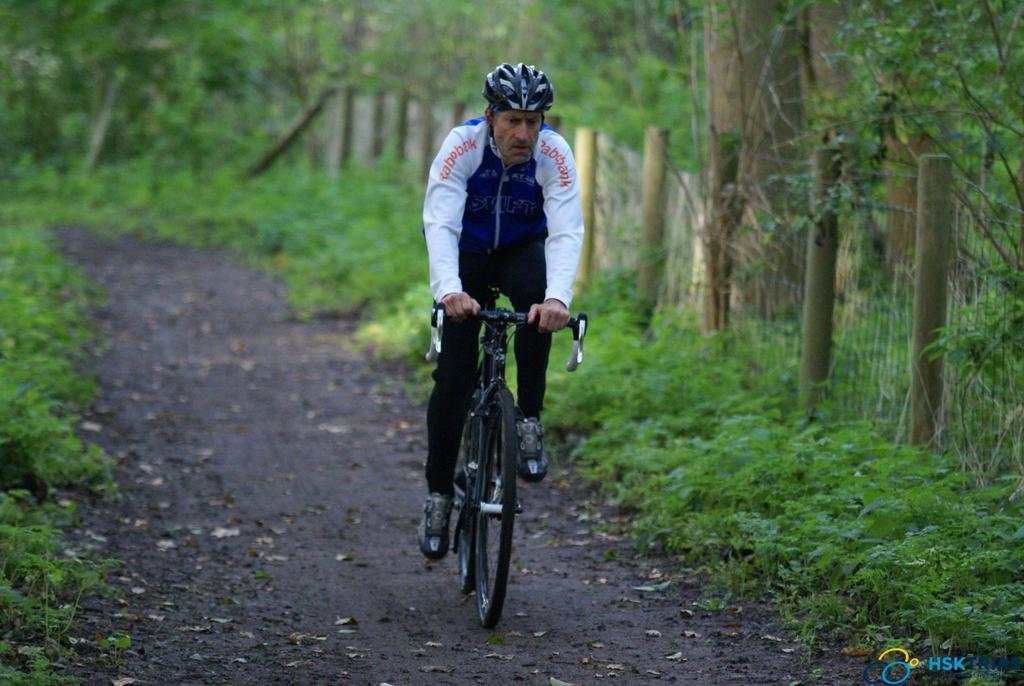What is the main subject of the image? There is a person riding a bicycle in the image. What can be seen in the background of the image? There are trees visible in the image. What is located on the right side of the image? There is a fence on the right side of the image. What type of vegetation is at the bottom of the image? There are plants at the bottom of the image. What type of support can be seen in the image for the person riding the bicycle? There is no support for the person riding the bicycle visible in the image; they are riding the bicycle independently. 